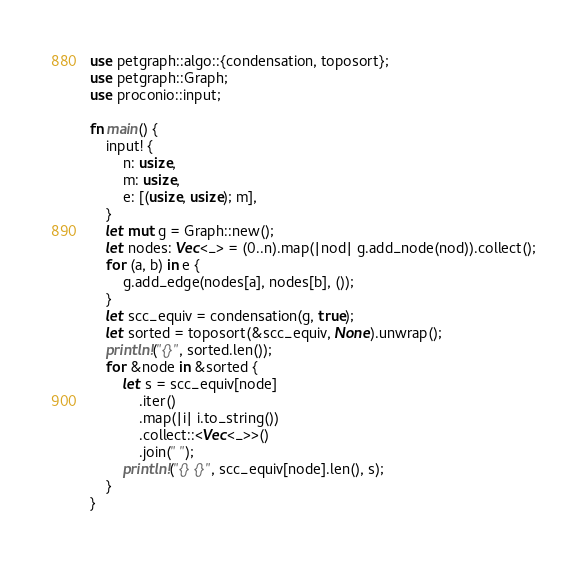<code> <loc_0><loc_0><loc_500><loc_500><_Rust_>use petgraph::algo::{condensation, toposort};
use petgraph::Graph;
use proconio::input;

fn main() {
    input! {
        n: usize,
        m: usize,
        e: [(usize, usize); m],
    }
    let mut g = Graph::new();
    let nodes: Vec<_> = (0..n).map(|nod| g.add_node(nod)).collect();
    for (a, b) in e {
        g.add_edge(nodes[a], nodes[b], ());
    }
    let scc_equiv = condensation(g, true);
    let sorted = toposort(&scc_equiv, None).unwrap();
    println!("{}", sorted.len());
    for &node in &sorted {
        let s = scc_equiv[node]
            .iter()
            .map(|i| i.to_string())
            .collect::<Vec<_>>()
            .join(" ");
        println!("{} {}", scc_equiv[node].len(), s);
    }
}
</code> 